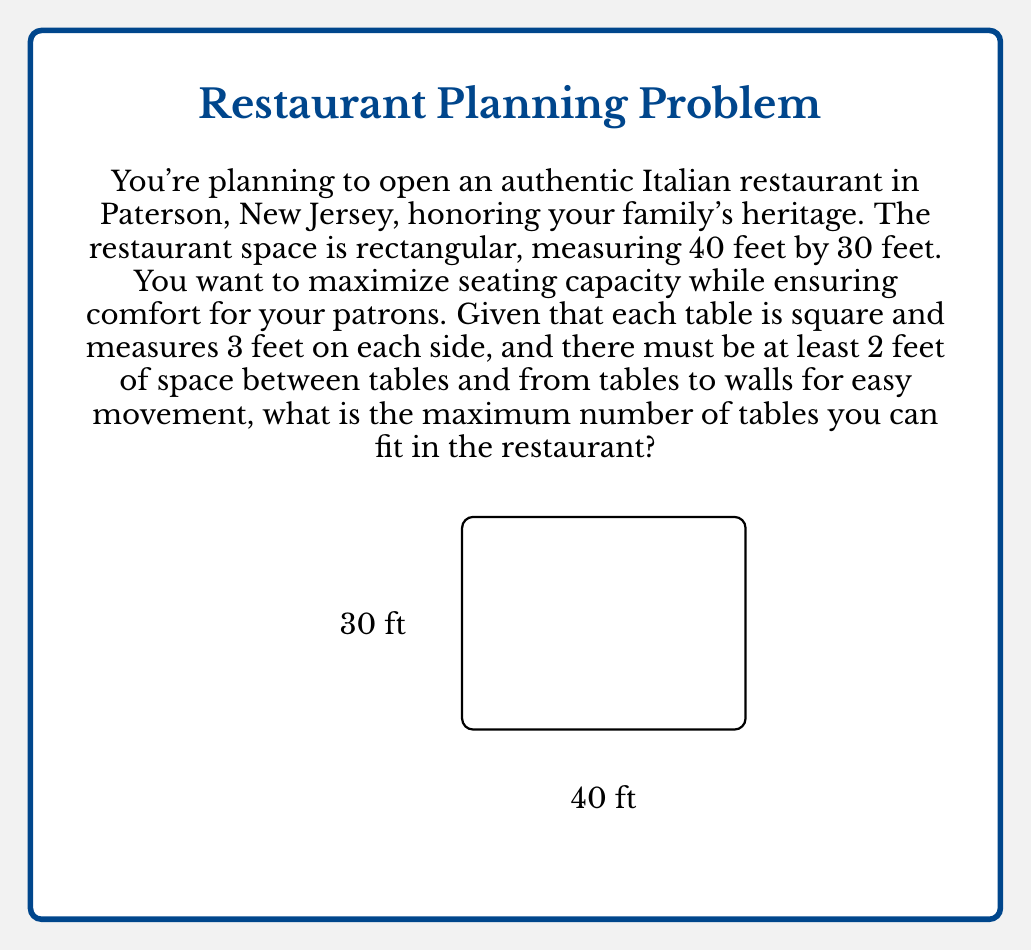Give your solution to this math problem. Let's approach this step-by-step:

1) First, we need to account for the space between tables and walls. With a 2-foot buffer on all sides, our usable space becomes:
   $$(40 - 2 - 2) \times (30 - 2 - 2) = 36 \text{ ft} \times 26 \text{ ft}$$

2) Now, we need to determine how much space each table occupies, including the required buffer zone. Each table is 3 feet wide, and we need 2 feet of space on each side:
   $$3 \text{ ft} + 2 \text{ ft} + 2 \text{ ft} = 7 \text{ ft}$$

3) Let's define variables:
   Let $x$ be the number of tables along the 36-foot length
   Let $y$ be the number of tables along the 26-foot width

4) We can set up two inequalities:
   $$7x \leq 36$$
   $$7y \leq 26$$

5) Solving these inequalities:
   $$x \leq \frac{36}{7} \approx 5.14$$
   $$y \leq \frac{26}{7} \approx 3.71$$

6) Since we can't have partial tables, we round down:
   $x = 5$ and $y = 3$

7) The total number of tables is therefore:
   $$5 \times 3 = 15 \text{ tables}$$

This arrangement optimizes the space while maintaining the required buffer zones for comfort and movement.
Answer: The maximum number of tables that can fit in the restaurant while maintaining the required spacing is 15 tables. 